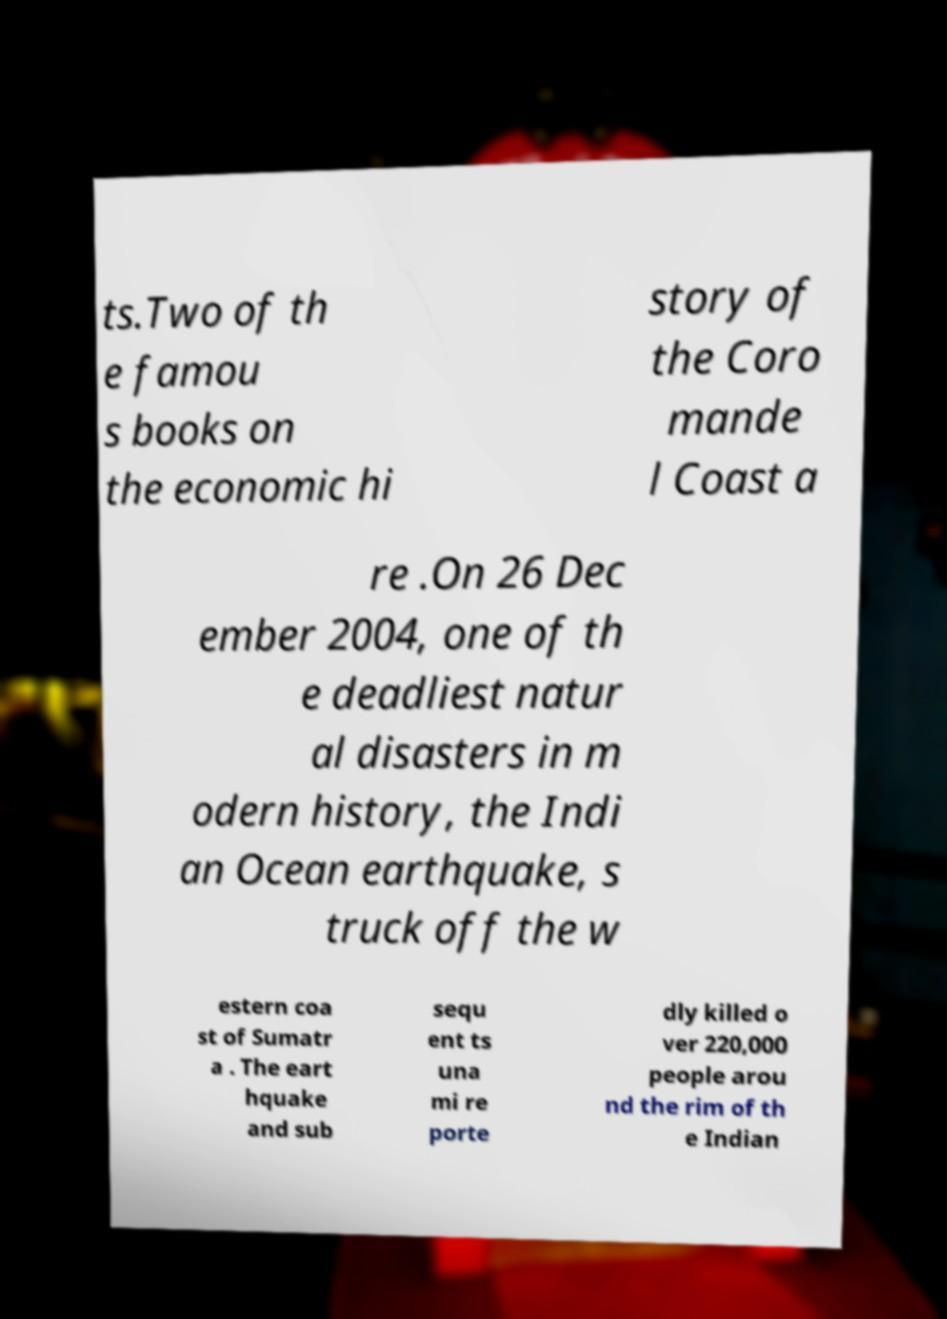There's text embedded in this image that I need extracted. Can you transcribe it verbatim? ts.Two of th e famou s books on the economic hi story of the Coro mande l Coast a re .On 26 Dec ember 2004, one of th e deadliest natur al disasters in m odern history, the Indi an Ocean earthquake, s truck off the w estern coa st of Sumatr a . The eart hquake and sub sequ ent ts una mi re porte dly killed o ver 220,000 people arou nd the rim of th e Indian 